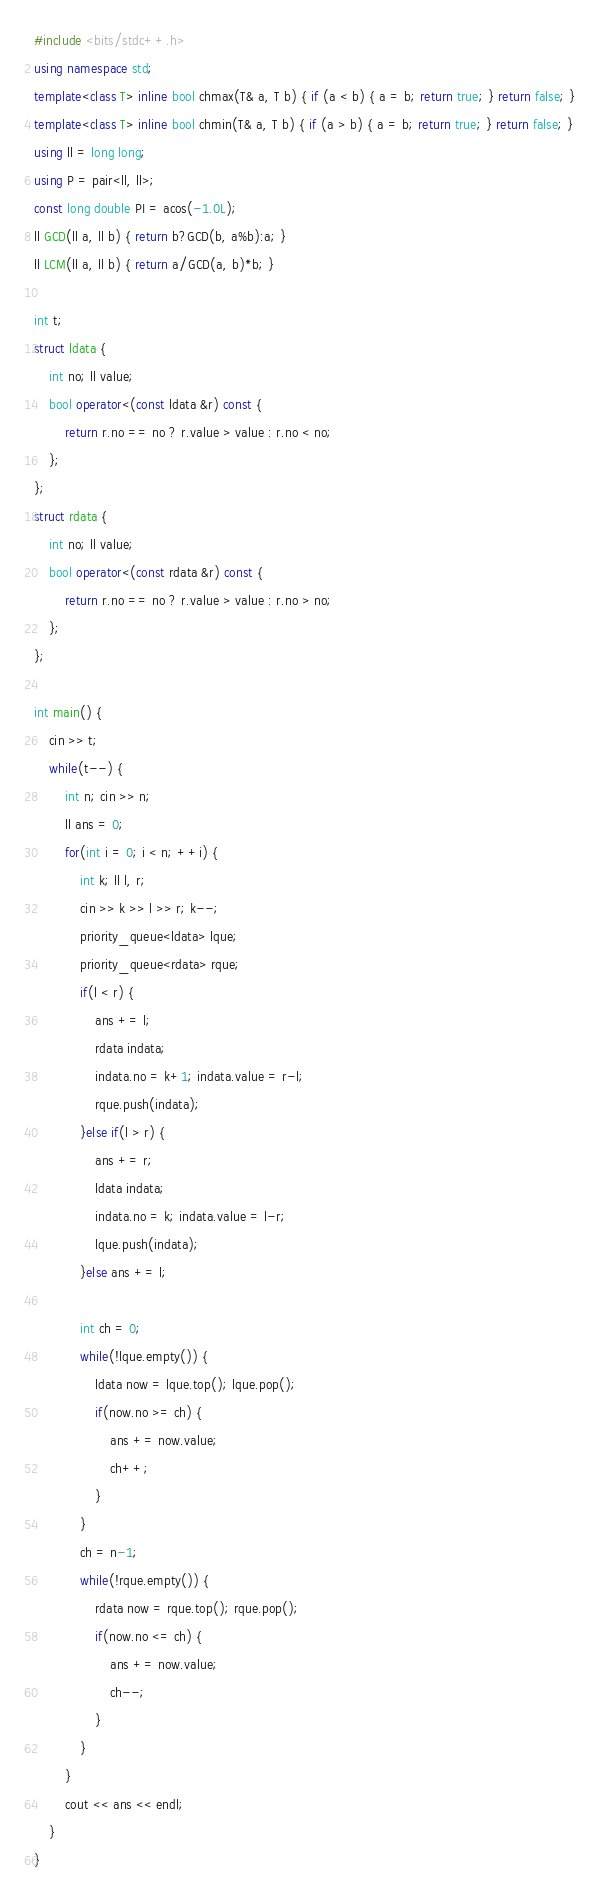<code> <loc_0><loc_0><loc_500><loc_500><_C++_>#include <bits/stdc++.h>
using namespace std;
template<class T> inline bool chmax(T& a, T b) { if (a < b) { a = b; return true; } return false; }
template<class T> inline bool chmin(T& a, T b) { if (a > b) { a = b; return true; } return false; }
using ll = long long;
using P = pair<ll, ll>;
const long double PI = acos(-1.0L);
ll GCD(ll a, ll b) { return b?GCD(b, a%b):a; }
ll LCM(ll a, ll b) { return a/GCD(a, b)*b; }

int t;
struct ldata {
    int no; ll value;
    bool operator<(const ldata &r) const {
        return r.no == no ? r.value > value : r.no < no;
    };
};
struct rdata {
    int no; ll value;
    bool operator<(const rdata &r) const {
        return r.no == no ? r.value > value : r.no > no;
    };
};

int main() {
    cin >> t;
    while(t--) {
        int n; cin >> n;
        ll ans = 0;
        for(int i = 0; i < n; ++i) {
            int k; ll l, r;
            cin >> k >> l >> r; k--;
            priority_queue<ldata> lque;
            priority_queue<rdata> rque;
            if(l < r) {
                ans += l;
                rdata indata;
                indata.no = k+1; indata.value = r-l;
                rque.push(indata);
            }else if(l > r) {
                ans += r;
                ldata indata;
                indata.no = k; indata.value = l-r;
                lque.push(indata);
            }else ans += l;

            int ch = 0;
            while(!lque.empty()) {
                ldata now = lque.top(); lque.pop();
                if(now.no >= ch) {
                    ans += now.value;
                    ch++;
                }
            }
            ch = n-1;
            while(!rque.empty()) {
                rdata now = rque.top(); rque.pop();
                if(now.no <= ch) {
                    ans += now.value;
                    ch--;
                }
            }
        }
        cout << ans << endl;
    }
}</code> 